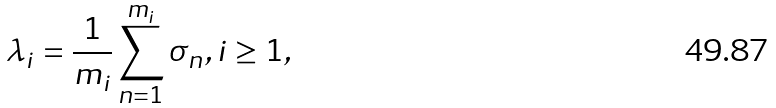<formula> <loc_0><loc_0><loc_500><loc_500>\lambda _ { i } = \frac { 1 } { m _ { i } } \sum _ { n = 1 } ^ { m _ { i } } \sigma _ { n } , i \geq 1 ,</formula> 